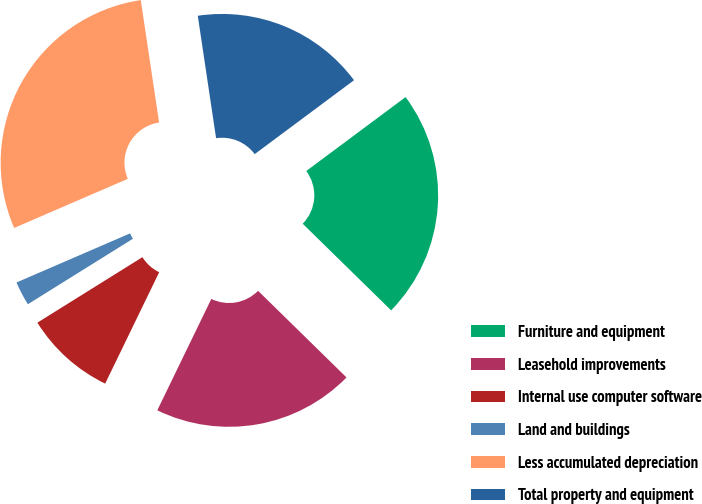Convert chart. <chart><loc_0><loc_0><loc_500><loc_500><pie_chart><fcel>Furniture and equipment<fcel>Leasehold improvements<fcel>Internal use computer software<fcel>Land and buildings<fcel>Less accumulated depreciation<fcel>Total property and equipment<nl><fcel>22.52%<fcel>19.85%<fcel>8.94%<fcel>2.38%<fcel>29.13%<fcel>17.18%<nl></chart> 